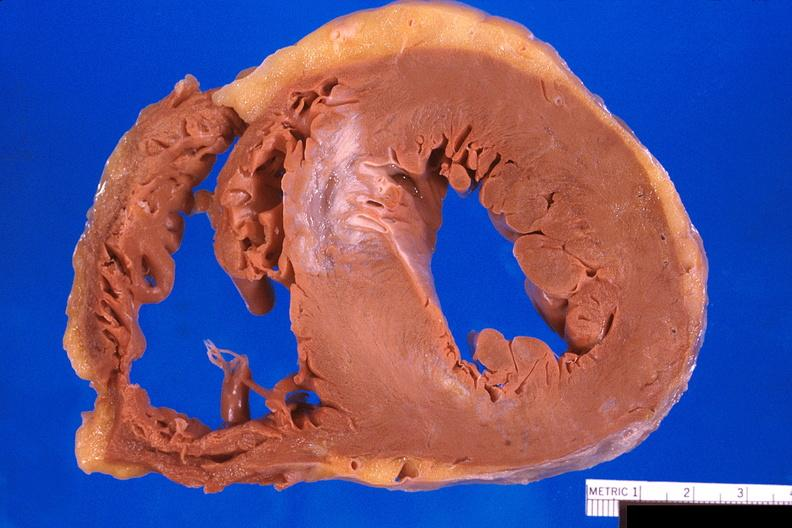does surface show heart, old myocardial infarction with fibrosis?
Answer the question using a single word or phrase. No 